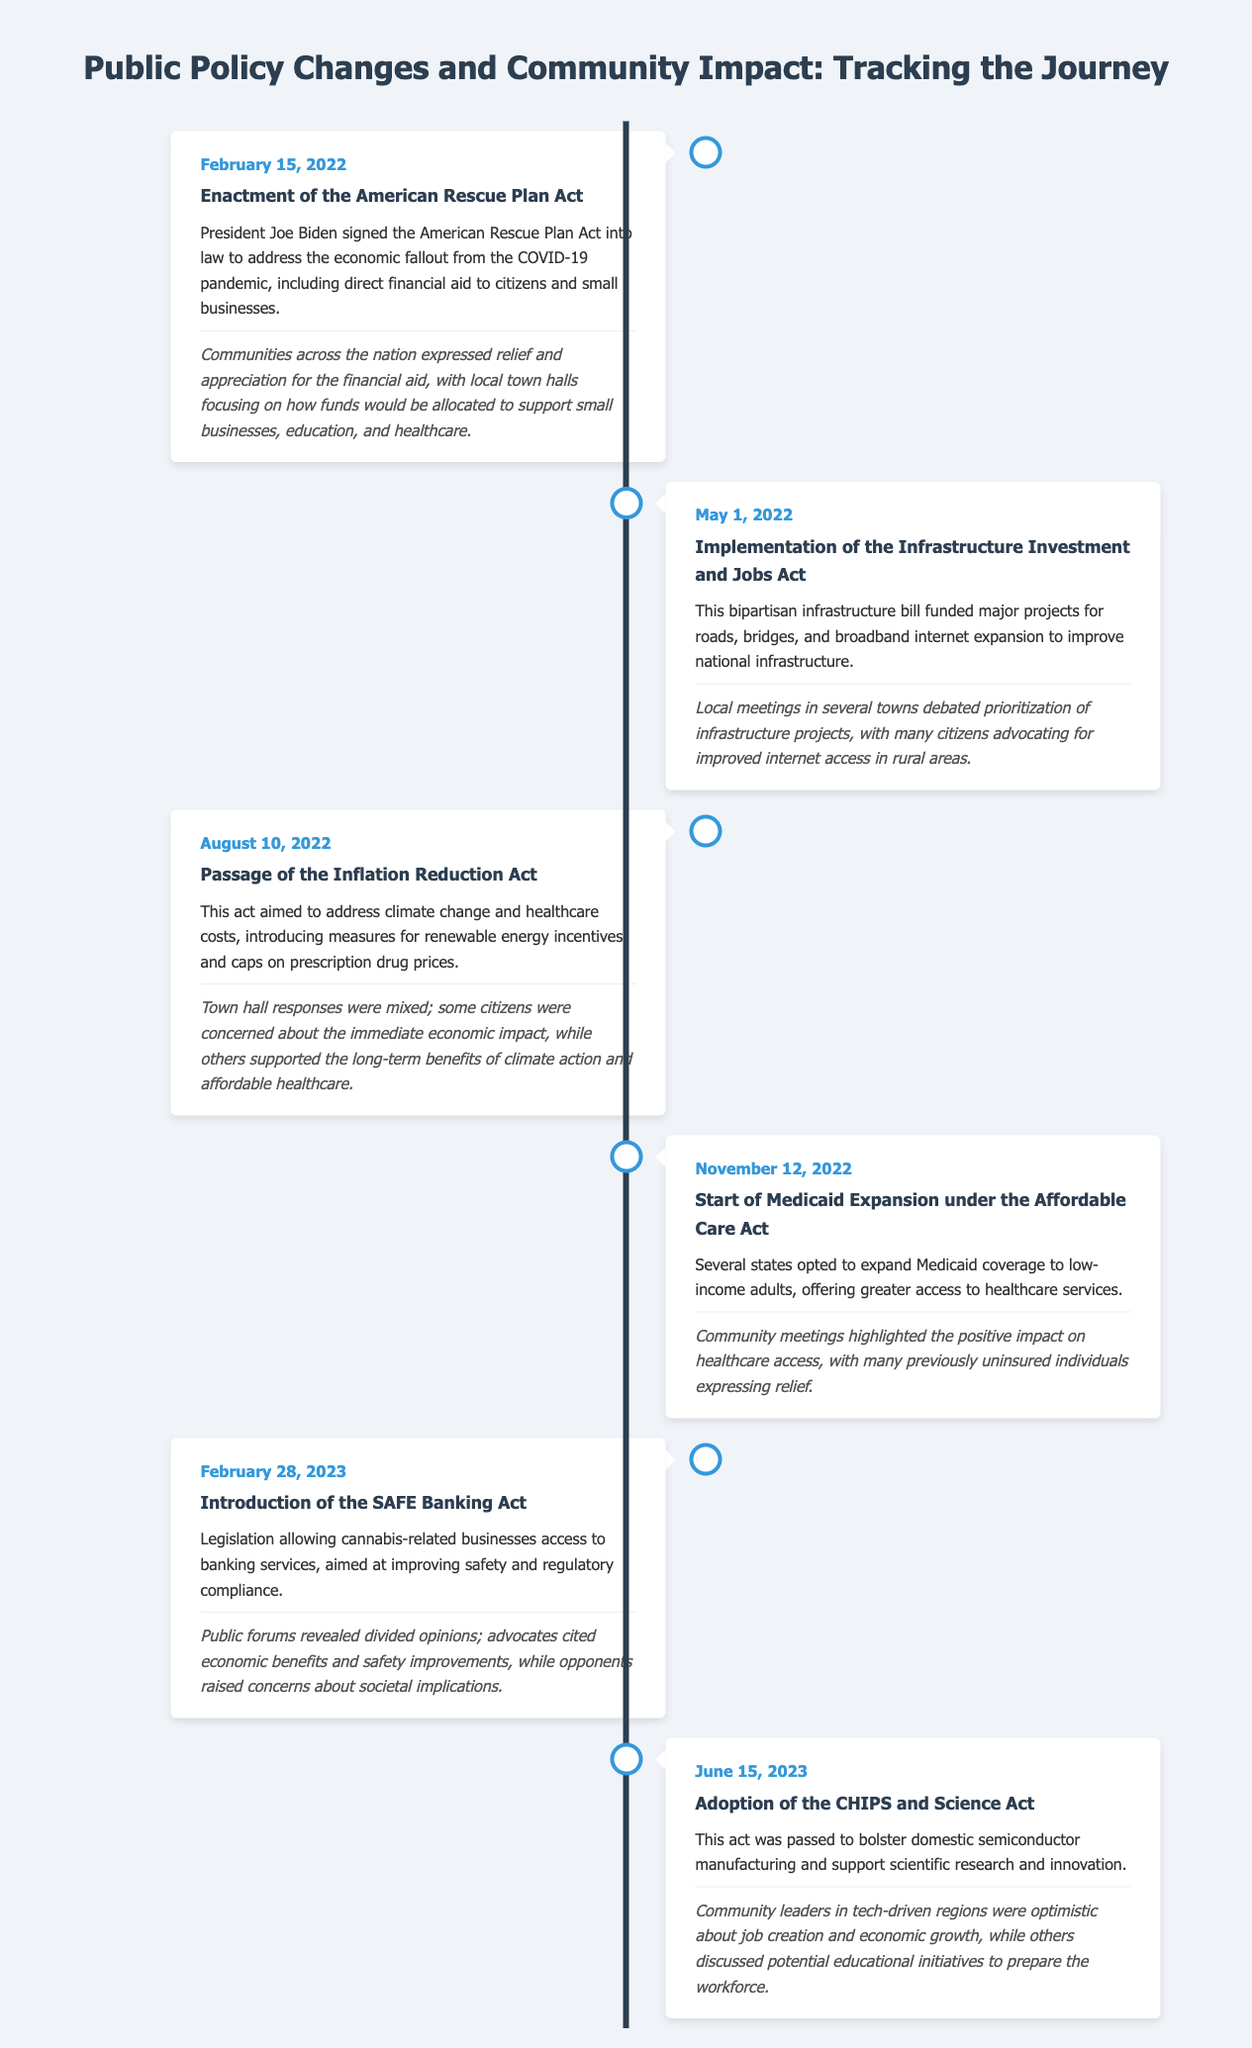What was enacted on February 15, 2022? The document states that the American Rescue Plan Act was signed into law on this date.
Answer: American Rescue Plan Act When did the Infrastructure Investment and Jobs Act begin implementation? This act was implemented on May 1, 2022, according to the timeline.
Answer: May 1, 2022 What is one of the aims of the Inflation Reduction Act passed on August 10, 2022? The document mentions addressing climate change as one of the aims of this act.
Answer: Climate change Which community issue was debated at local meetings regarding the Infrastructure Investment and Jobs Act? The document highlights that the prioritization of infrastructure projects, especially internet access in rural areas, was debated.
Answer: Internet access What significant change occurred on November 12, 2022? The start of Medicaid expansion under the Affordable Care Act happened on this date.
Answer: Medicaid expansion According to the community response, who expressed relief due to the Medicaid expansion? The document states that previously uninsured individuals expressed relief regarding their access to healthcare.
Answer: Previously uninsured individuals What does the SAFE Banking Act allow? It allows cannabis-related businesses access to banking services as noted in the timeline.
Answer: Access to banking services Which act was passed on June 15, 2023? The CHIPS and Science Act was adopted on this date, as per the timeline.
Answer: CHIPS and Science Act What kind of responses were there to the SAFE Banking Act in public forums? The document notes that there were divided opinions regarding economic benefits and societal implications.
Answer: Divided opinions 